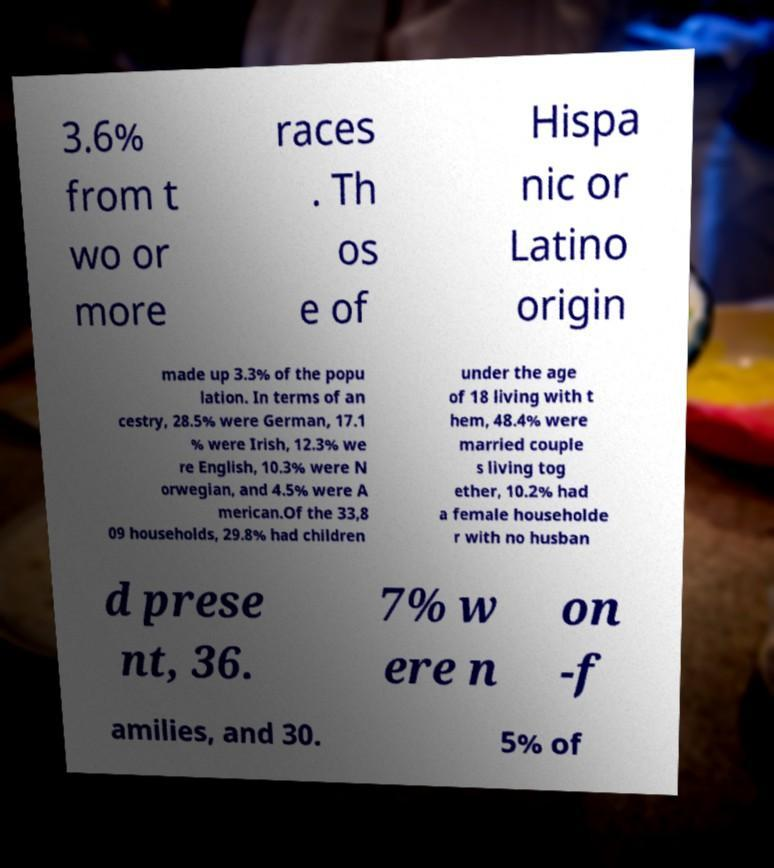Please read and relay the text visible in this image. What does it say? 3.6% from t wo or more races . Th os e of Hispa nic or Latino origin made up 3.3% of the popu lation. In terms of an cestry, 28.5% were German, 17.1 % were Irish, 12.3% we re English, 10.3% were N orwegian, and 4.5% were A merican.Of the 33,8 09 households, 29.8% had children under the age of 18 living with t hem, 48.4% were married couple s living tog ether, 10.2% had a female householde r with no husban d prese nt, 36. 7% w ere n on -f amilies, and 30. 5% of 